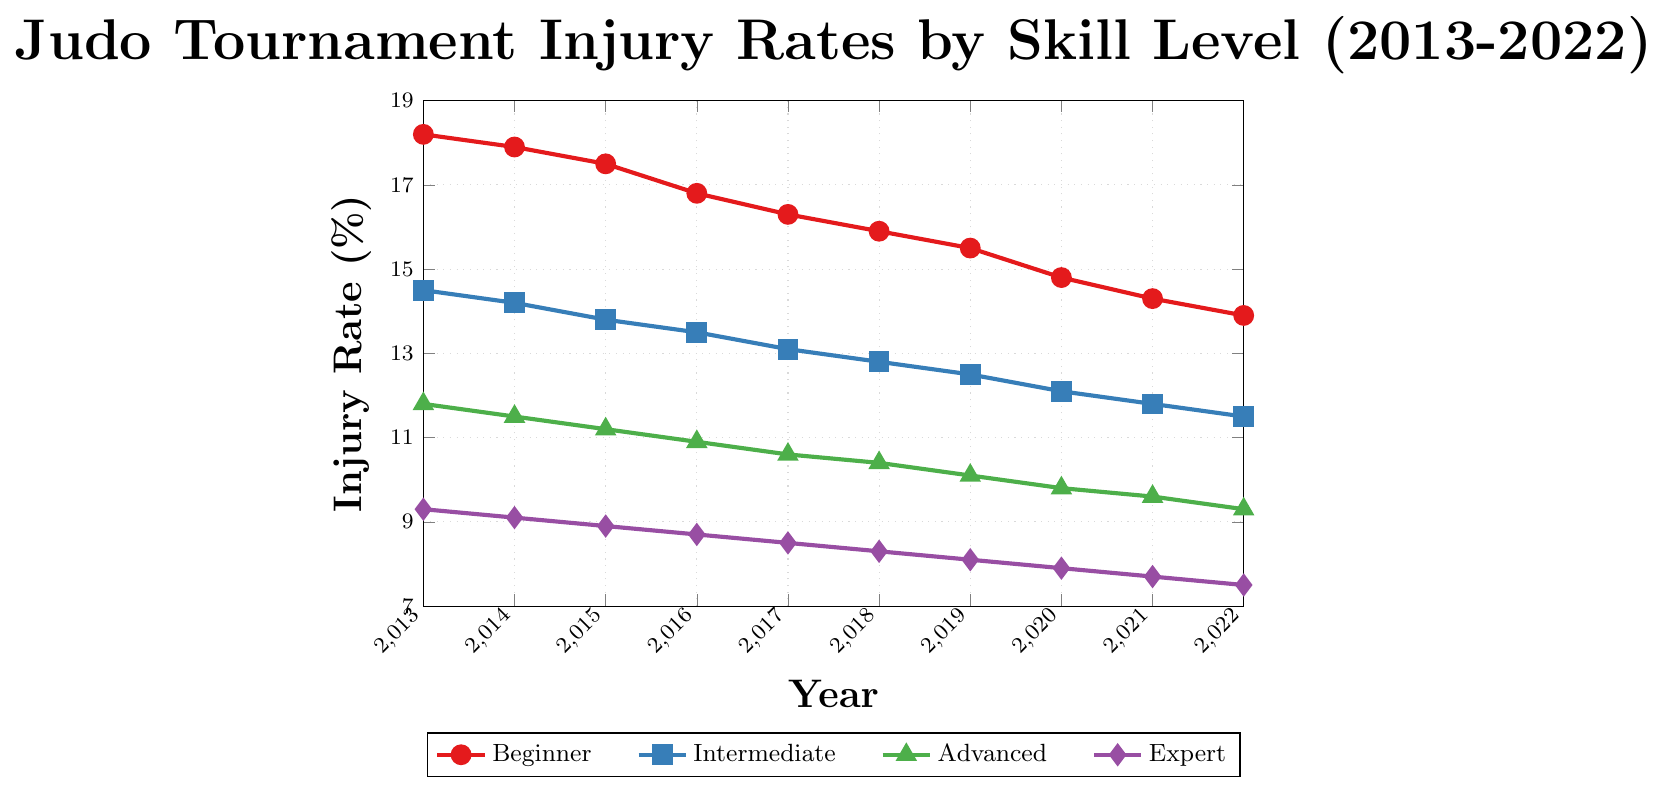Which skill level has the highest injury rate in 2022? By looking at the end of the lines on the chart for the year 2022, the line representing the beginners (red) has the highest position on the Y-axis.
Answer: Beginner How did the injury rate for experts change from 2013 to 2022? Check the start and end points of the purple line. In 2013, the injury rate was 9.3% for experts, and it decreased to 7.5% in 2022, indicating a reduction.
Answer: Decreased What is the difference in injury rates between beginners and intermediate practitioners in 2019? Locate the values for beginners and intermediate in 2019 from the respective lines. For beginners, it is 15.5%, and for intermediate practitioners, it is 12.5%. The difference is 15.5% - 12.5% = 3%.
Answer: 3% Which year saw the largest decrease in injury rate for advanced practitioners? By observing the green line, the largest drop occurred between 2014 and 2015, where the rate decreased from 11.5% to 11.2%, which is a 0.3% difference.
Answer: 2014-2015 Which group showed a consistent decrease in injury rates across all years? By visually inspecting the plot, all groups show a consistent decrease in injury rates, as the lines slant downwards without any increase.
Answer: All groups What was the average injury rate for intermediate practitioners between 2017 and 2022? Sum the injury rates for intermediate practitioners from 2017 to 2022: 13.1 + 12.8 + 12.5 + 12.1 + 11.8 + 11.5 = 73.8. Divide by the number of years (6), yielding an average of 73.8 / 6 ≈ 12.3%.
Answer: 12.3% Which skill level experienced the smallest change in injury rate from 2013 to 2022? Calculate the change for each skill level. Beginners: 18.2 - 13.9 = 4.3%, Intermediate: 14.5 - 11.5 = 3%, Advanced: 11.8 - 9.3 = 2.5%, Expert: 9.3 - 7.5 = 1.8%. Experts experienced the smallest change.
Answer: Expert By how much did the injury rate for beginners decrease annually on average? Subtract the 2022 injury rate of beginners from the 2013 rate: 18.2 - 13.9 = 4.3%. Divide by the number of years (2022-2013 = 9). The average annual decrease is 4.3 / 9 ≈ 0.478%.
Answer: 0.478% In which year did the expert skill level see an injury rate below 8% for the first time? Observe the purple line and find the first year the rate drops below 8%. In 2019, the rate was 8.1%, and in 2020 it was 7.9%, so the first time below 8% was in 2020.
Answer: 2020 Does the plot suggest a correlation between skill level and injury rates? Visually, it is clear that as the skill level increases (from beginner to expert), the injury rates decrease. This suggests a negative correlation between skill level and injury rates.
Answer: Yes 